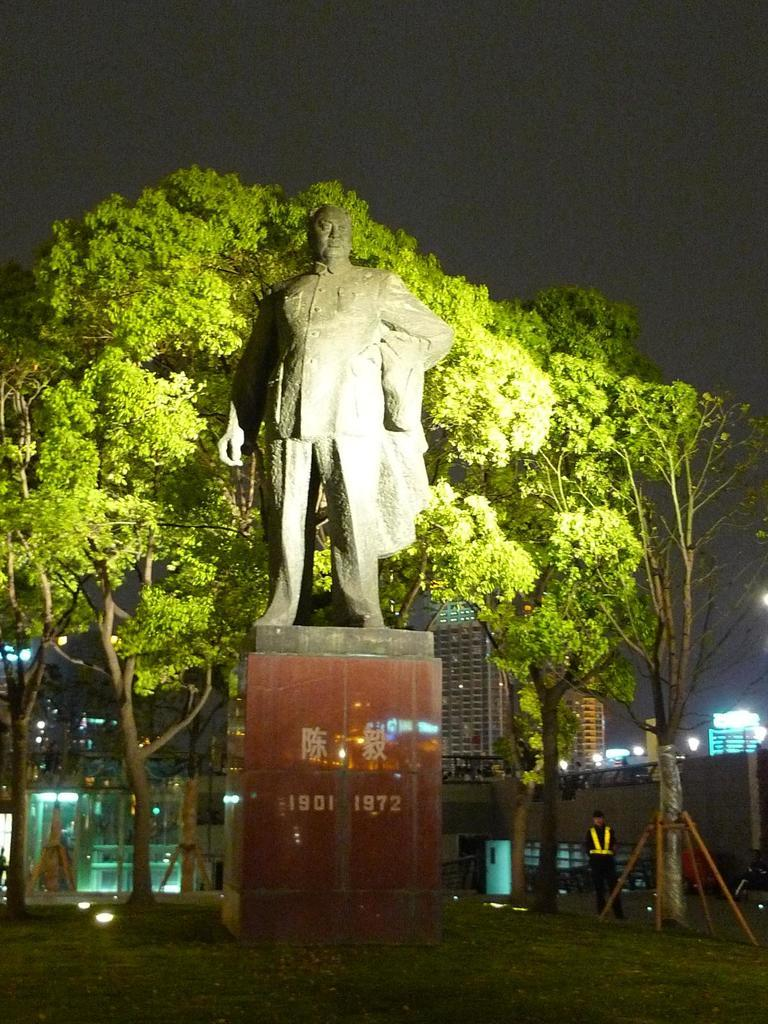What is the main subject in the image? There is a statue in the image. How is the statue positioned in the image? The statue is on a pedestal. What type of natural elements can be seen in the image? There are trees in the image. What type of man-made structures are visible in the image? There are buildings in the image. What part of the sky is visible in the image? The sky is visible in the image. Can you describe the person in the image? There is a person in the image. What type of lighting is present in the image? There are lights in the image. What type of surface is visible at the bottom of the image? The ground is visible in the image. What type of badge is the person wearing while driving the truck in the image? There is no person driving a truck in the image, nor is there any mention of a badge. 